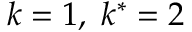Convert formula to latex. <formula><loc_0><loc_0><loc_500><loc_500>k = 1 , \, k ^ { * } = 2</formula> 